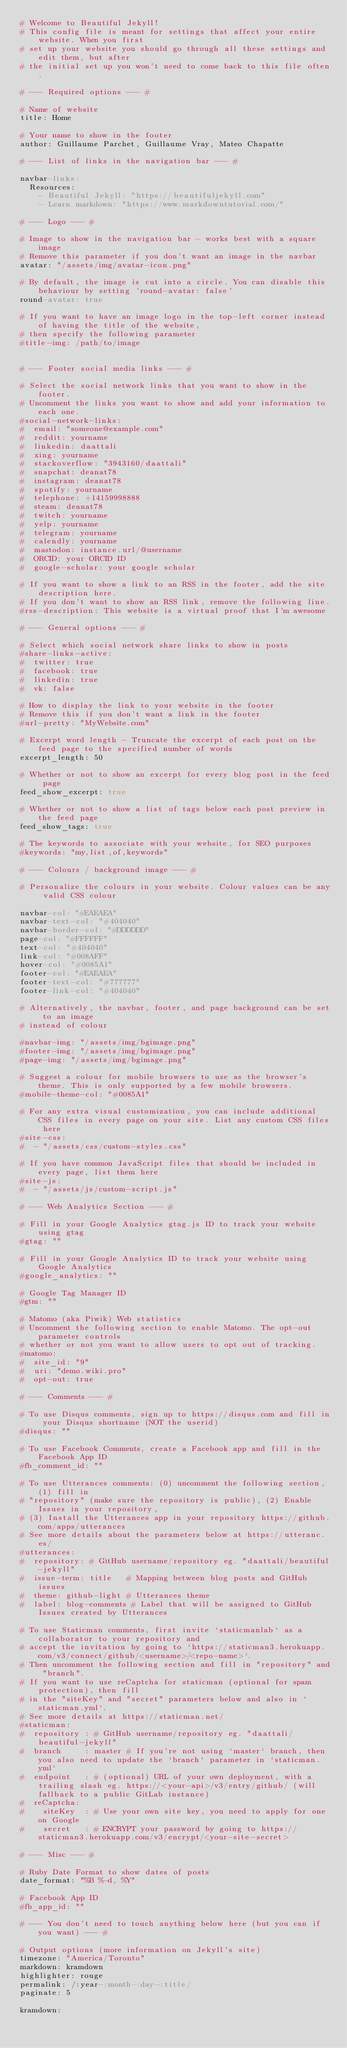<code> <loc_0><loc_0><loc_500><loc_500><_YAML_># Welcome to Beautiful Jekyll!
# This config file is meant for settings that affect your entire website. When you first
# set up your website you should go through all these settings and edit them, but after
# the initial set up you won't need to come back to this file often.

# --- Required options --- #

# Name of website
title: Home

# Your name to show in the footer
author: Guillaume Parchet, Guillaume Vray, Mateo Chapatte

# --- List of links in the navigation bar --- #

navbar-links:
  Resources:
    - Beautiful Jekyll: "https://beautifuljekyll.com"
    - Learn markdown: "https://www.markdowntutorial.com/"

# --- Logo --- #

# Image to show in the navigation bar - works best with a square image
# Remove this parameter if you don't want an image in the navbar
avatar: "/assets/img/avatar-icon.png"

# By default, the image is cut into a circle. You can disable this behaviour by setting 'round-avatar: false'
round-avatar: true

# If you want to have an image logo in the top-left corner instead of having the title of the website,
# then specify the following parameter
#title-img: /path/to/image


# --- Footer social media links --- #

# Select the social network links that you want to show in the footer.
# Uncomment the links you want to show and add your information to each one.
#social-network-links:
#  email: "someone@example.com"
#  reddit: yourname
#  linkedin: daattali
#  xing: yourname
#  stackoverflow: "3943160/daattali"
#  snapchat: deanat78
#  instagram: deanat78
#  spotify: yourname
#  telephone: +14159998888
#  steam: deanat78
#  twitch: yourname
#  yelp: yourname
#  telegram: yourname
#  calendly: yourname
#  mastodon: instance.url/@username
#  ORCID: your ORCID ID
#  google-scholar: your google scholar

# If you want to show a link to an RSS in the footer, add the site description here.
# If you don't want to show an RSS link, remove the following line.
#rss-description: This website is a virtual proof that I'm awesome

# --- General options --- #

# Select which social network share links to show in posts
#share-links-active:
#  twitter: true
#  facebook: true
#  linkedin: true
#  vk: false

# How to display the link to your website in the footer
# Remove this if you don't want a link in the footer
#url-pretty: "MyWebsite.com"

# Excerpt word length - Truncate the excerpt of each post on the feed page to the specified number of words
excerpt_length: 50

# Whether or not to show an excerpt for every blog post in the feed page
feed_show_excerpt: true

# Whether or not to show a list of tags below each post preview in the feed page
feed_show_tags: true

# The keywords to associate with your website, for SEO purposes
#keywords: "my,list,of,keywords"

# --- Colours / background image --- #

# Personalize the colours in your website. Colour values can be any valid CSS colour

navbar-col: "#EAEAEA"
navbar-text-col: "#404040"
navbar-border-col: "#DDDDDD"
page-col: "#FFFFFF"
text-col: "#404040"
link-col: "#008AFF"
hover-col: "#0085A1"
footer-col: "#EAEAEA"
footer-text-col: "#777777"
footer-link-col: "#404040"

# Alternatively, the navbar, footer, and page background can be set to an image
# instead of colour

#navbar-img: "/assets/img/bgimage.png"
#footer-img: "/assets/img/bgimage.png"
#page-img: "/assets/img/bgimage.png"

# Suggest a colour for mobile browsers to use as the browser's theme. This is only supported by a few mobile browsers.
#mobile-theme-col: "#0085A1"

# For any extra visual customization, you can include additional CSS files in every page on your site. List any custom CSS files here
#site-css:
#  - "/assets/css/custom-styles.css"

# If you have common JavaScript files that should be included in every page, list them here
#site-js:
#  - "/assets/js/custom-script.js"

# --- Web Analytics Section --- #

# Fill in your Google Analytics gtag.js ID to track your website using gtag
#gtag: ""

# Fill in your Google Analytics ID to track your website using Google Analytics
#google_analytics: ""

# Google Tag Manager ID
#gtm: ""

# Matomo (aka Piwik) Web statistics
# Uncomment the following section to enable Matomo. The opt-out parameter controls
# whether or not you want to allow users to opt out of tracking.
#matomo:
#  site_id: "9"
#  uri: "demo.wiki.pro"
#  opt-out: true

# --- Comments --- #

# To use Disqus comments, sign up to https://disqus.com and fill in your Disqus shortname (NOT the userid)
#disqus: ""

# To use Facebook Comments, create a Facebook app and fill in the Facebook App ID
#fb_comment_id: ""

# To use Utterances comments: (0) uncomment the following section, (1) fill in
# "repository" (make sure the repository is public), (2) Enable Issues in your repository,
# (3) Install the Utterances app in your repository https://github.com/apps/utterances
# See more details about the parameters below at https://utteranc.es/
#utterances:
#  repository: # GitHub username/repository eg. "daattali/beautiful-jekyll"
#  issue-term: title   # Mapping between blog posts and GitHub issues
#  theme: github-light # Utterances theme
#  label: blog-comments # Label that will be assigned to GitHub Issues created by Utterances

# To use Staticman comments, first invite `staticmanlab` as a collaborator to your repository and
# accept the invitation by going to `https://staticman3.herokuapp.com/v3/connect/github/<username>/<repo-name>`.
# Then uncomment the following section and fill in "repository" and "branch".
# If you want to use reCaptcha for staticman (optional for spam protection), then fill
# in the "siteKey" and "secret" parameters below and also in `staticman.yml`.
# See more details at https://staticman.net/
#staticman:
#  repository : # GitHub username/repository eg. "daattali/beautiful-jekyll"
#  branch     : master # If you're not using `master` branch, then you also need to update the `branch` parameter in `staticman.yml`
#  endpoint   : # (optional) URL of your own deployment, with a trailing slash eg. https://<your-api>/v3/entry/github/ (will fallback to a public GitLab instance)
#  reCaptcha:
#    siteKey  : # Use your own site key, you need to apply for one on Google
#    secret   : # ENCRYPT your password by going to https://staticman3.herokuapp.com/v3/encrypt/<your-site-secret>

# --- Misc --- #

# Ruby Date Format to show dates of posts
date_format: "%B %-d, %Y"

# Facebook App ID
#fb_app_id: ""

# --- You don't need to touch anything below here (but you can if you want) --- #

# Output options (more information on Jekyll's site)
timezone: "America/Toronto"
markdown: kramdown
highlighter: rouge
permalink: /:year-:month-:day-:title/
paginate: 5

kramdown:</code> 